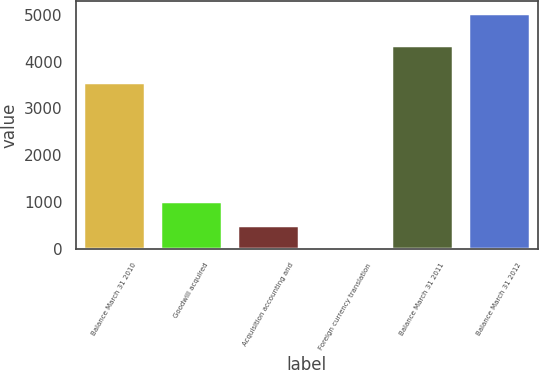<chart> <loc_0><loc_0><loc_500><loc_500><bar_chart><fcel>Balance March 31 2010<fcel>Goodwill acquired<fcel>Acquisition accounting and<fcel>Foreign currency translation<fcel>Balance March 31 2011<fcel>Balance March 31 2012<nl><fcel>3568<fcel>1017.6<fcel>515.8<fcel>14<fcel>4364<fcel>5032<nl></chart> 